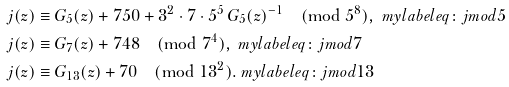Convert formula to latex. <formula><loc_0><loc_0><loc_500><loc_500>j ( z ) & \equiv G _ { 5 } ( z ) + 7 5 0 + 3 ^ { 2 } \cdot 7 \cdot 5 ^ { 5 } \, G _ { 5 } ( z ) ^ { - 1 } \pmod { 5 ^ { 8 } } , \ m y l a b e l { e q \colon j m o d 5 } \\ j ( z ) & \equiv G _ { 7 } ( z ) + 7 4 8 \pmod { 7 ^ { 4 } } , \ m y l a b e l { e q \colon j m o d 7 } \\ j ( z ) & \equiv G _ { 1 3 } ( z ) + 7 0 \pmod { 1 3 ^ { 2 } } . \ m y l a b e l { e q \colon j m o d 1 3 }</formula> 